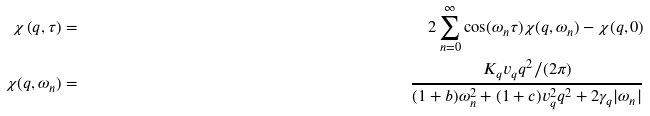<formula> <loc_0><loc_0><loc_500><loc_500>\chi \left ( q , \tau \right ) & = & 2 \sum _ { n = 0 } ^ { \infty } \cos ( \omega _ { n } \tau ) \chi ( q , \omega _ { n } ) - \chi ( q , 0 ) \\ \chi ( q , \omega _ { n } ) & = & \frac { K _ { q } v _ { q } q ^ { 2 } / ( 2 \pi ) } { ( 1 + b ) \omega _ { n } ^ { 2 } + ( 1 + c ) v _ { q } ^ { 2 } q ^ { 2 } + 2 \gamma _ { q } | \omega _ { n } | }</formula> 